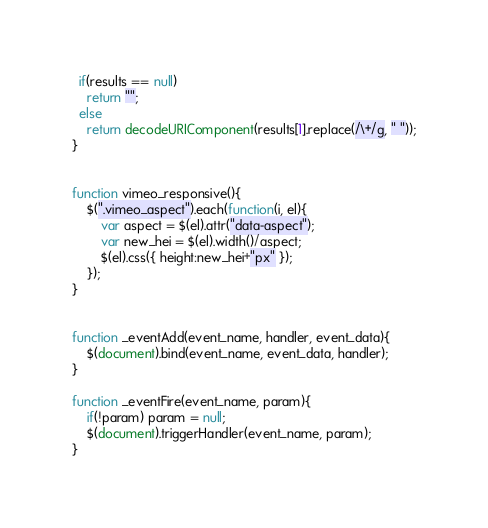<code> <loc_0><loc_0><loc_500><loc_500><_JavaScript_>  if(results == null)
    return "";
  else
    return decodeURIComponent(results[1].replace(/\+/g, " "));
}


function vimeo_responsive(){
	$(".vimeo_aspect").each(function(i, el){
		var aspect = $(el).attr("data-aspect");
		var new_hei = $(el).width()/aspect;
		$(el).css({ height:new_hei+"px" });
	});
}


function _eventAdd(event_name, handler, event_data){
	$(document).bind(event_name, event_data, handler);
}

function _eventFire(event_name, param){
	if(!param) param = null;
	$(document).triggerHandler(event_name, param);
}

</code> 